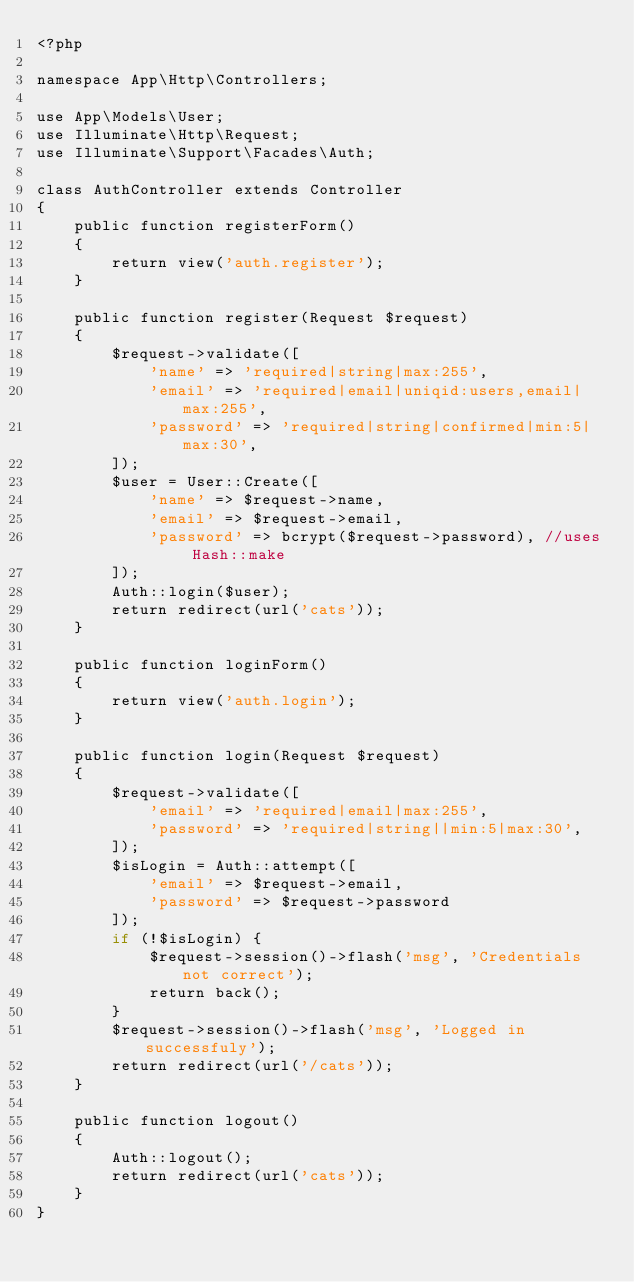<code> <loc_0><loc_0><loc_500><loc_500><_PHP_><?php

namespace App\Http\Controllers;

use App\Models\User;
use Illuminate\Http\Request;
use Illuminate\Support\Facades\Auth;

class AuthController extends Controller
{
    public function registerForm()
    {
        return view('auth.register');
    }

    public function register(Request $request)
    {
        $request->validate([
            'name' => 'required|string|max:255',
            'email' => 'required|email|uniqid:users,email|max:255',
            'password' => 'required|string|confirmed|min:5|max:30',
        ]);
        $user = User::Create([
            'name' => $request->name,
            'email' => $request->email,
            'password' => bcrypt($request->password), //uses Hash::make 
        ]);
        Auth::login($user);
        return redirect(url('cats'));
    }

    public function loginForm()
    {
        return view('auth.login');
    }

    public function login(Request $request)
    {
        $request->validate([
            'email' => 'required|email|max:255',
            'password' => 'required|string||min:5|max:30',
        ]);
        $isLogin = Auth::attempt([
            'email' => $request->email,
            'password' => $request->password
        ]);
        if (!$isLogin) {
            $request->session()->flash('msg', 'Credentials not correct');
            return back();
        }
        $request->session()->flash('msg', 'Logged in successfuly');
        return redirect(url('/cats'));
    }

    public function logout()
    {
        Auth::logout();
        return redirect(url('cats'));
    }
}
</code> 